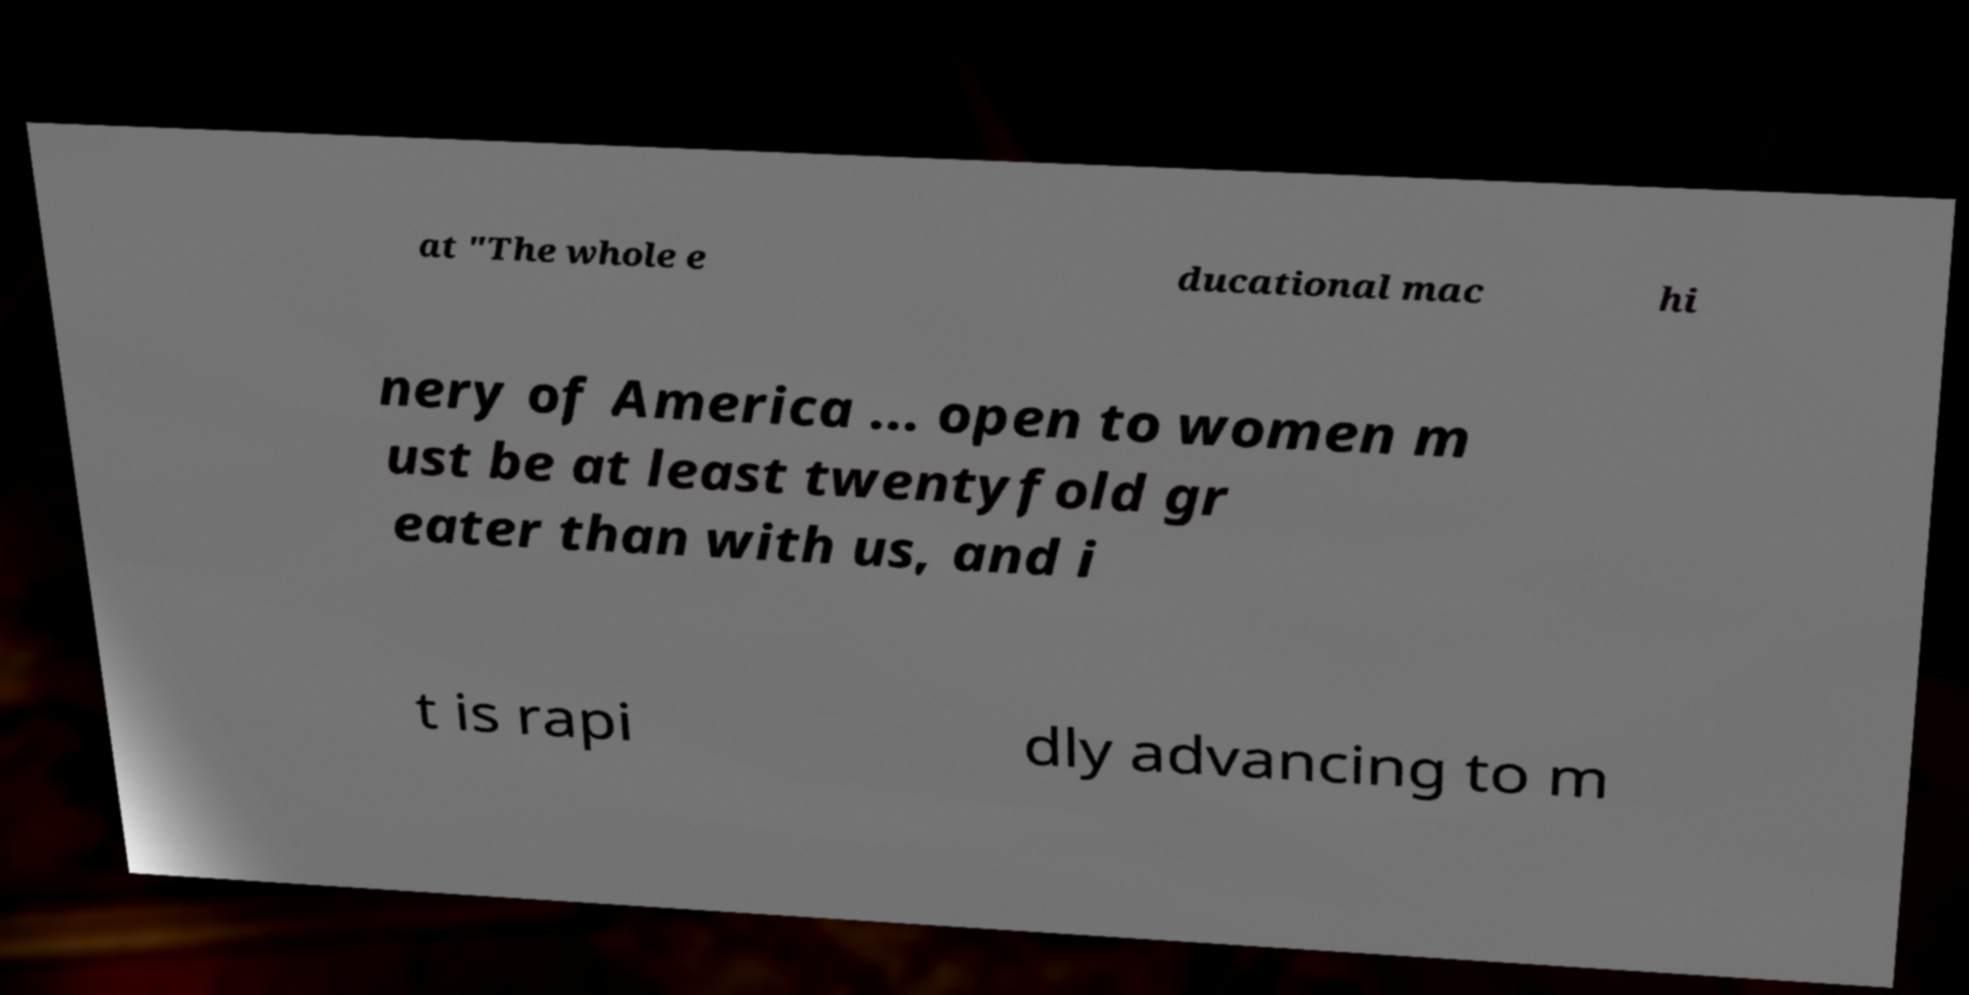I need the written content from this picture converted into text. Can you do that? at "The whole e ducational mac hi nery of America ... open to women m ust be at least twentyfold gr eater than with us, and i t is rapi dly advancing to m 